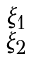Convert formula to latex. <formula><loc_0><loc_0><loc_500><loc_500>\begin{smallmatrix} \xi _ { 1 } \\ \xi _ { 2 } \end{smallmatrix}</formula> 